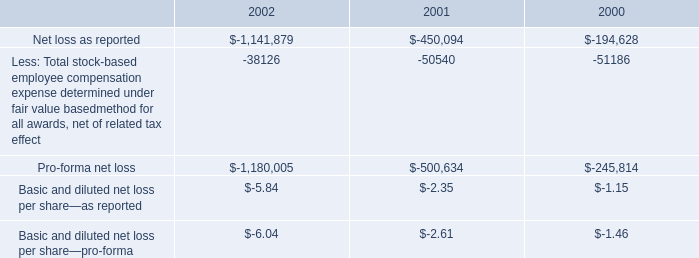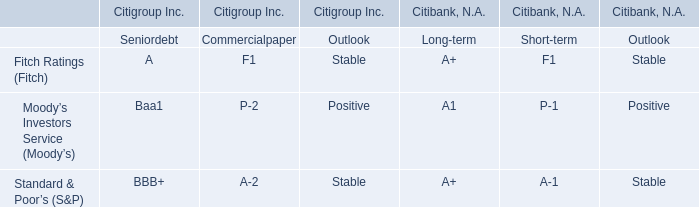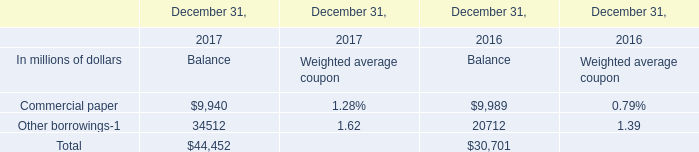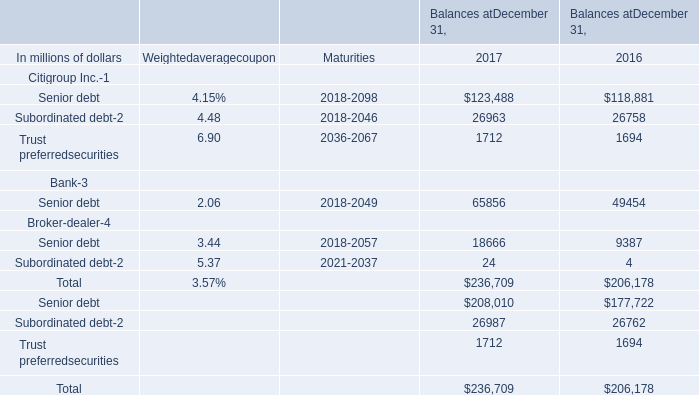what is the percentage change in 401 ( k ) contributions from 2001 to 2002? 
Computations: ((979000 - 1540000) / 1540000)
Answer: -0.36429. 